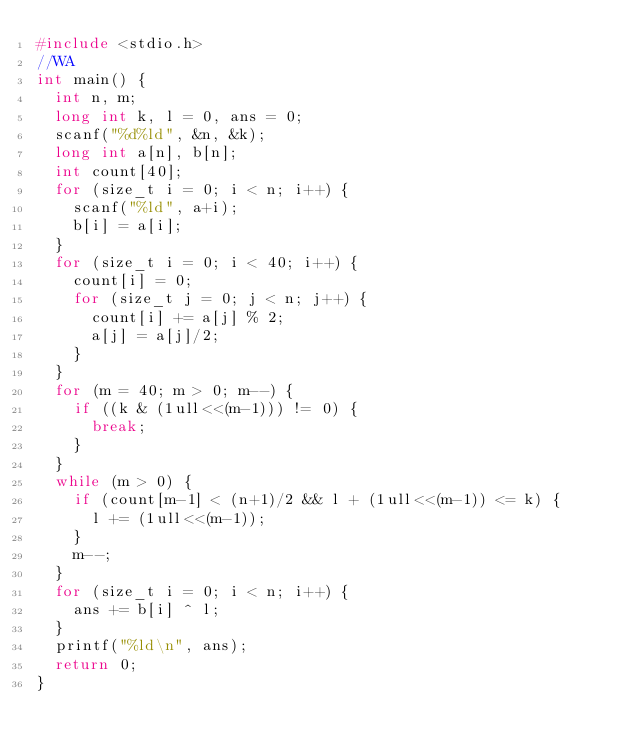Convert code to text. <code><loc_0><loc_0><loc_500><loc_500><_C_>#include <stdio.h>
//WA
int main() {
  int n, m;
  long int k, l = 0, ans = 0;
  scanf("%d%ld", &n, &k);
  long int a[n], b[n];
  int count[40];
  for (size_t i = 0; i < n; i++) {
    scanf("%ld", a+i);
    b[i] = a[i];
  }
  for (size_t i = 0; i < 40; i++) {
    count[i] = 0;
    for (size_t j = 0; j < n; j++) {
      count[i] += a[j] % 2;
      a[j] = a[j]/2;
    }
  }
  for (m = 40; m > 0; m--) {
    if ((k & (1ull<<(m-1))) != 0) {
      break;
    }
  }
  while (m > 0) {
    if (count[m-1] < (n+1)/2 && l + (1ull<<(m-1)) <= k) {
      l += (1ull<<(m-1));
    }
    m--;
  }
  for (size_t i = 0; i < n; i++) {
    ans += b[i] ^ l;
  }
  printf("%ld\n", ans);
  return 0;
}
</code> 